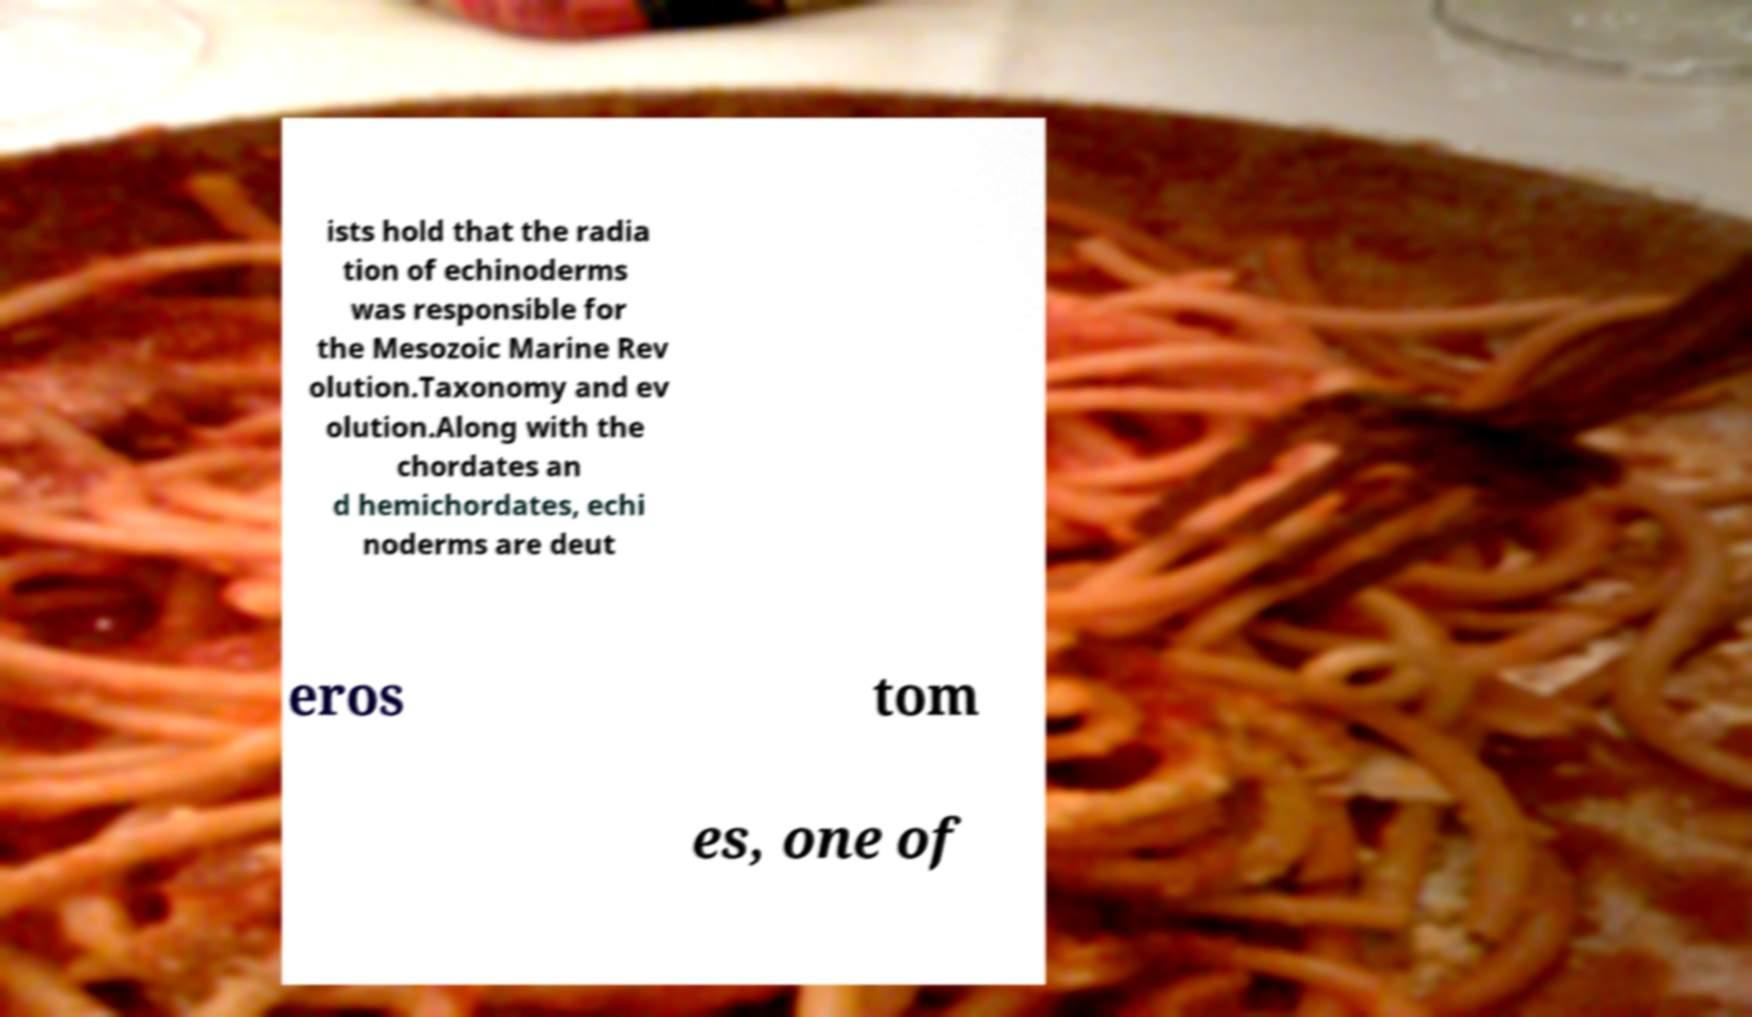Can you read and provide the text displayed in the image?This photo seems to have some interesting text. Can you extract and type it out for me? ists hold that the radia tion of echinoderms was responsible for the Mesozoic Marine Rev olution.Taxonomy and ev olution.Along with the chordates an d hemichordates, echi noderms are deut eros tom es, one of 